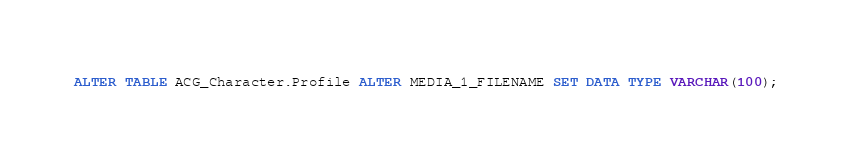<code> <loc_0><loc_0><loc_500><loc_500><_SQL_>ALTER TABLE ACG_Character.Profile ALTER MEDIA_1_FILENAME SET DATA TYPE VARCHAR(100);
</code> 